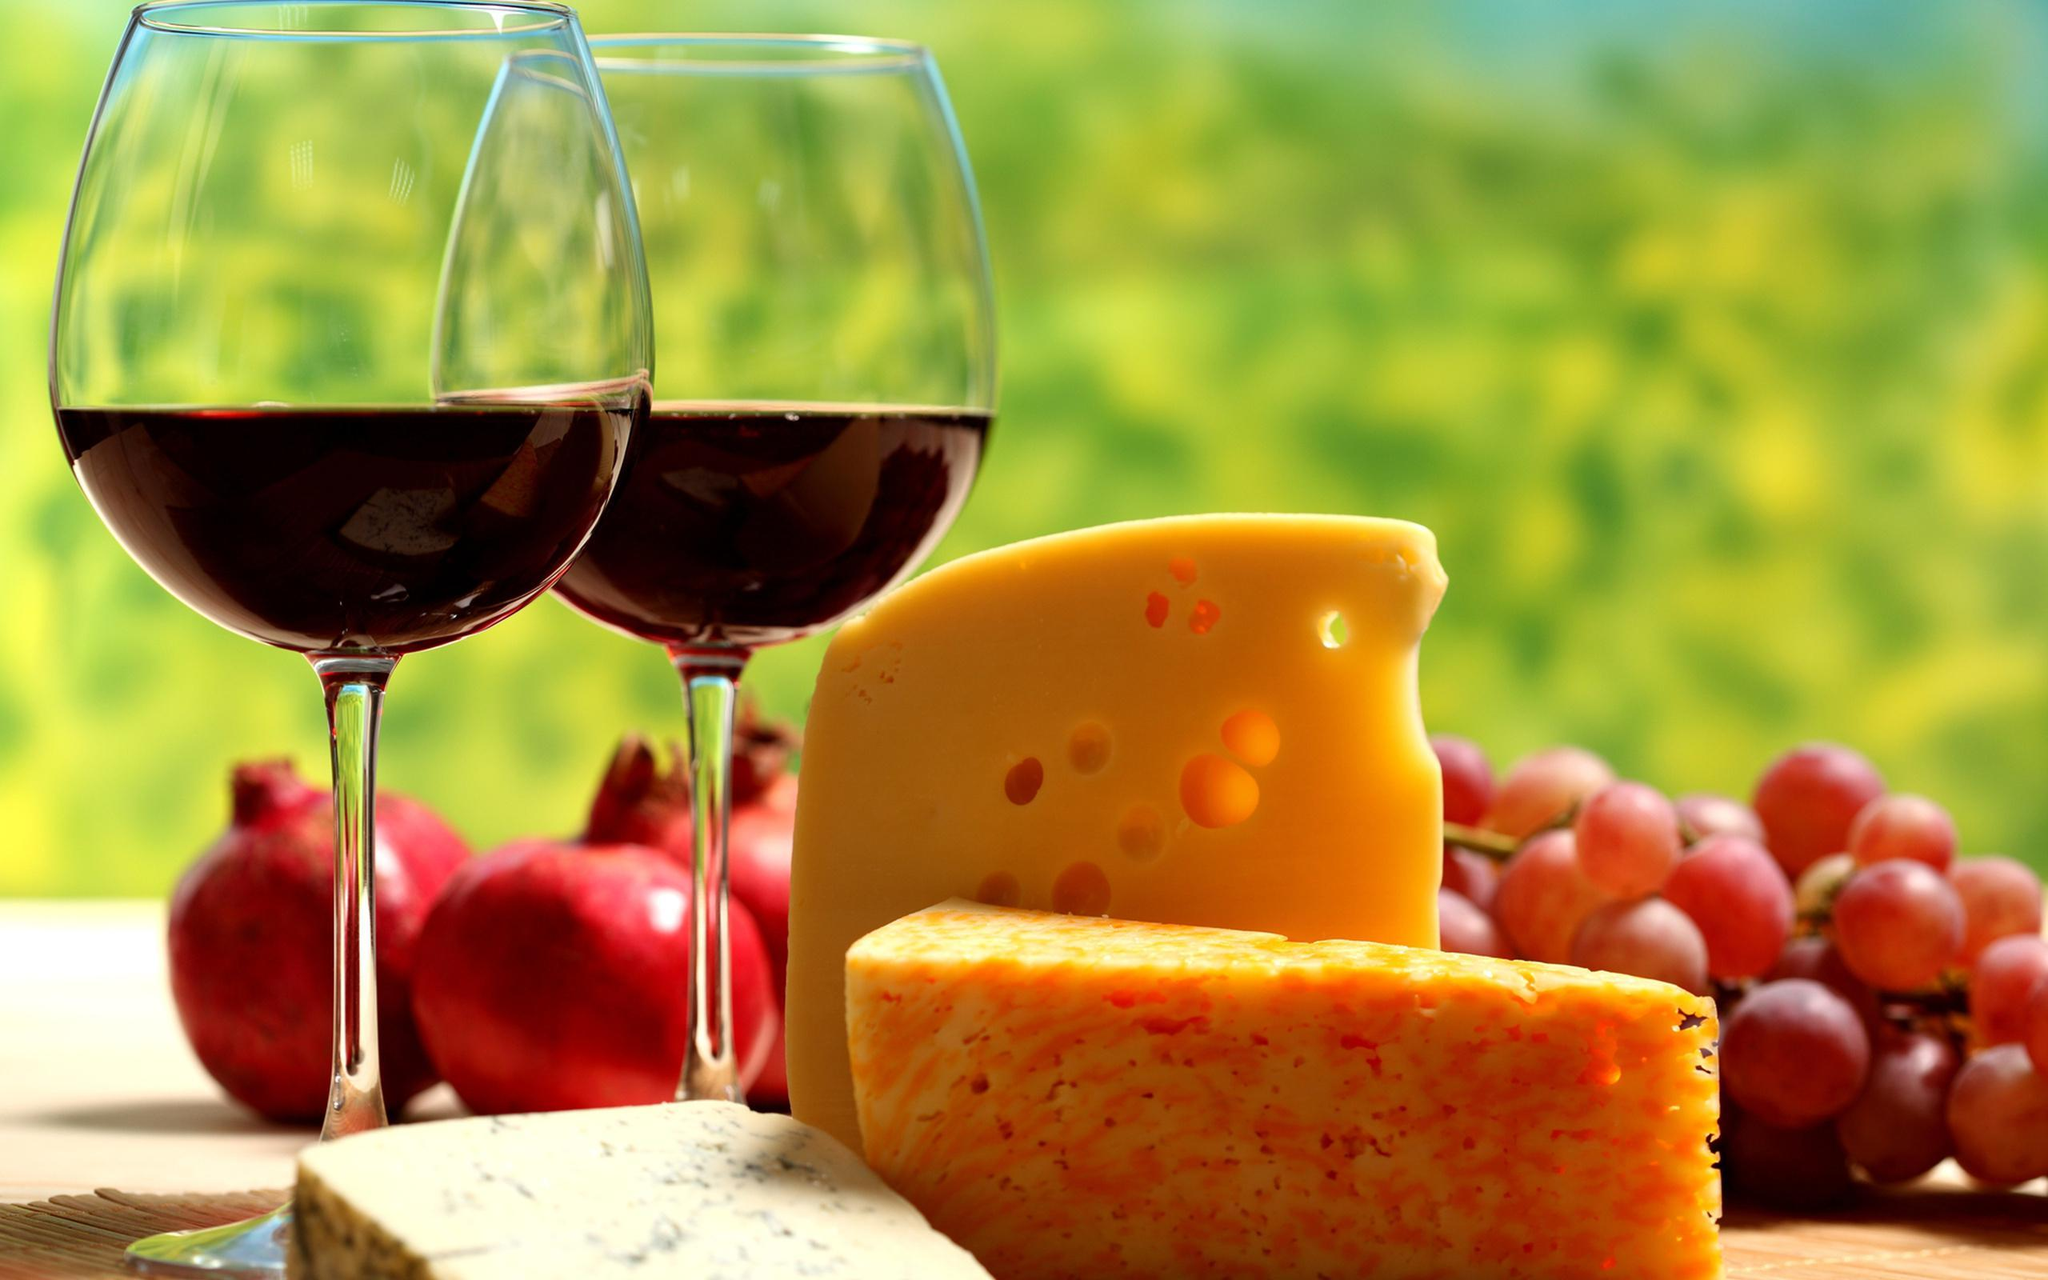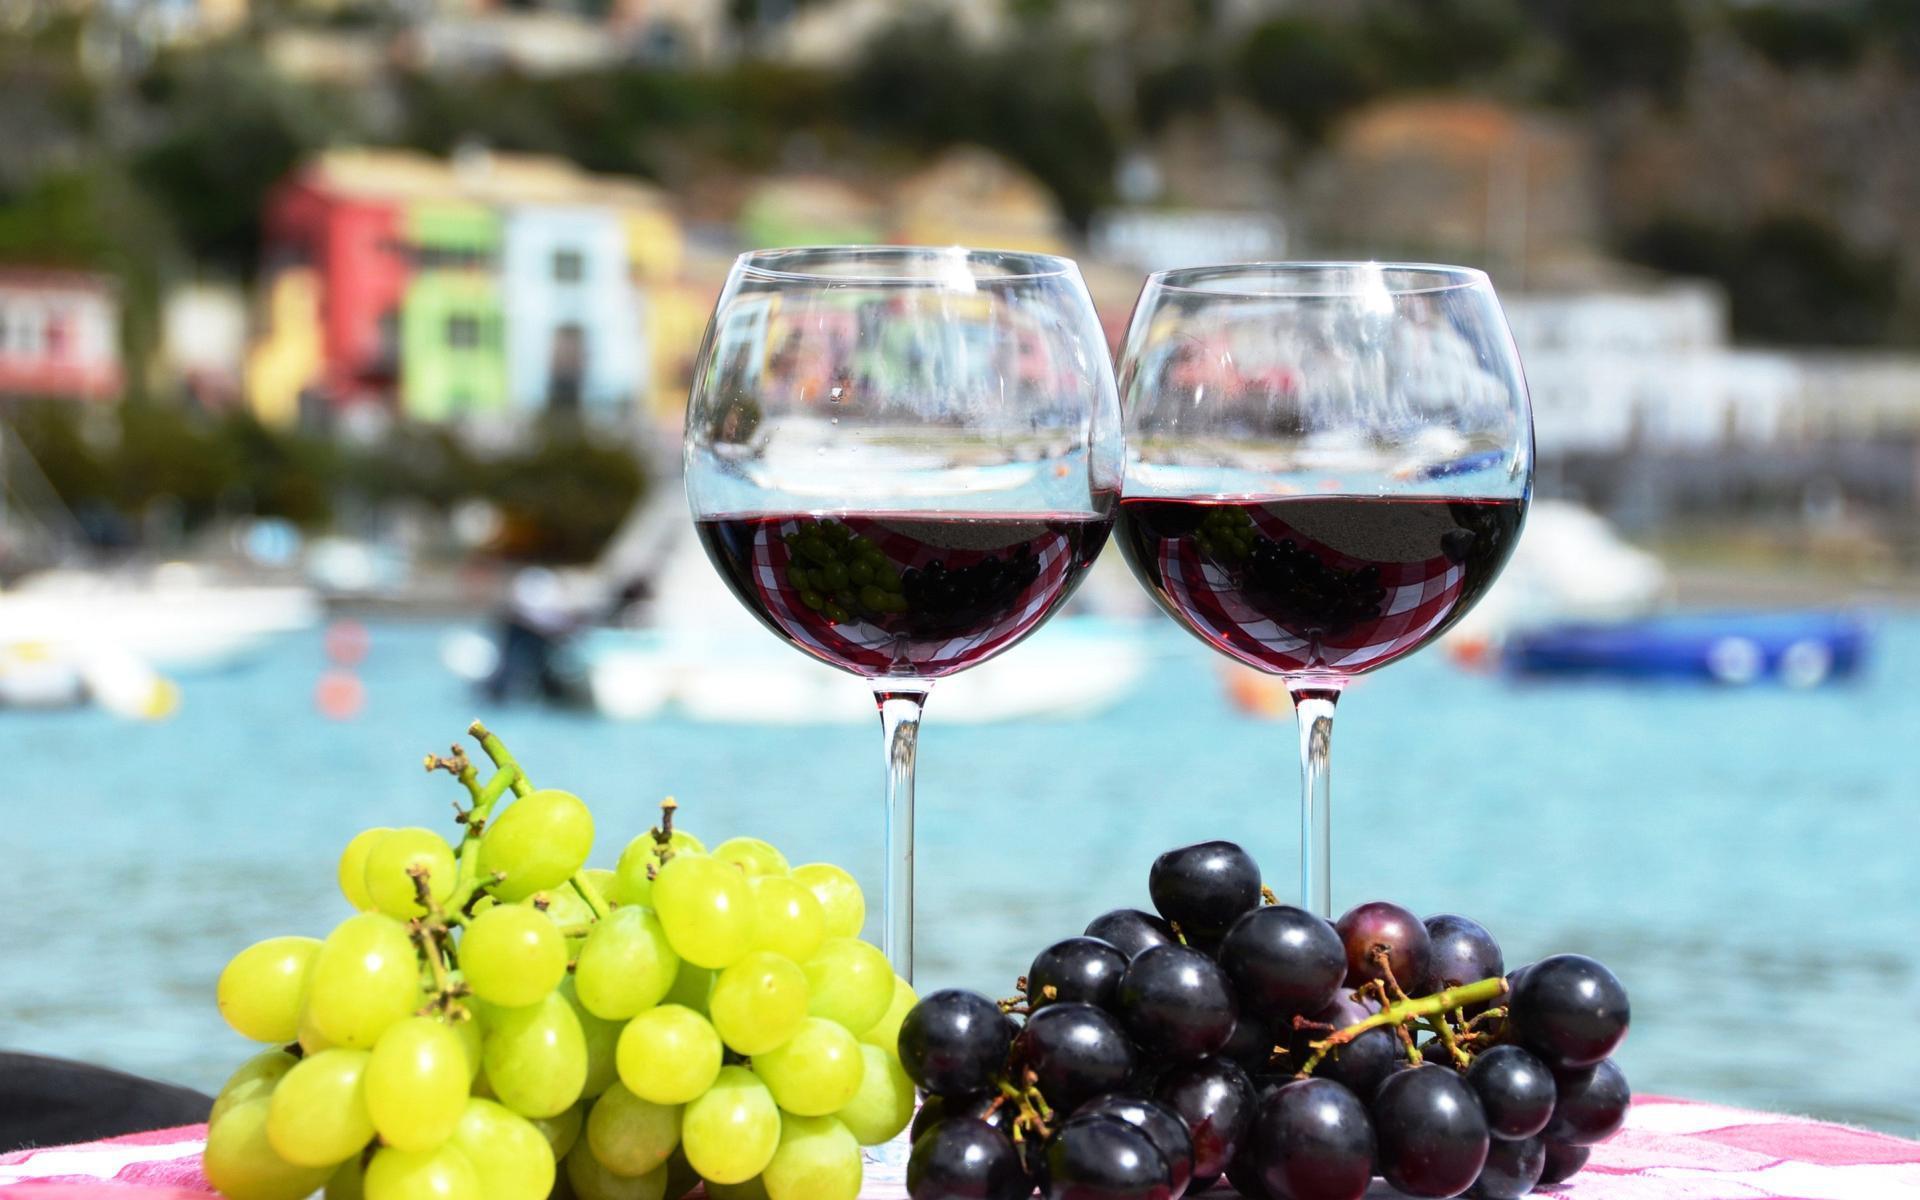The first image is the image on the left, the second image is the image on the right. Given the left and right images, does the statement "The wine glasses are near wicker picnic baskets." hold true? Answer yes or no. No. 